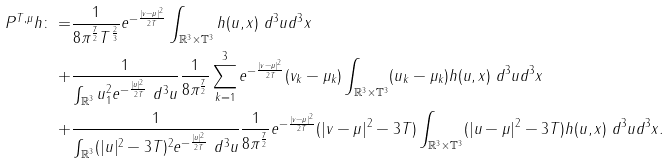<formula> <loc_0><loc_0><loc_500><loc_500>P ^ { T , \mu } h \colon = & \frac { 1 } { 8 \pi ^ { \frac { 7 } { 2 } } T ^ { \frac { 2 } { 3 } } } e ^ { - \frac { | v - \mu | ^ { 2 } } { 2 T } } \int _ { \mathbb { R } ^ { 3 } \times \mathbb { T } ^ { 3 } } h ( u , x ) \ d ^ { 3 } u d ^ { 3 } x \\ + & \frac { 1 } { \int _ { \mathbb { R } ^ { 3 } } u _ { 1 } ^ { 2 } e ^ { - \frac { | u | ^ { 2 } } { 2 T } } \ d ^ { 3 } u } \frac { 1 } { 8 \pi ^ { \frac { 7 } { 2 } } } \sum _ { k = 1 } ^ { 3 } e ^ { - \frac { | v - \mu | ^ { 2 } } { 2 T } } ( v _ { k } - \mu _ { k } ) \int _ { \mathbb { R } ^ { 3 } \times \mathbb { T } ^ { 3 } } ( u _ { k } - \mu _ { k } ) h ( u , x ) \ d ^ { 3 } u d ^ { 3 } x \\ + & \frac { 1 } { \int _ { \mathbb { R } ^ { 3 } } ( | u | ^ { 2 } - 3 T ) ^ { 2 } e ^ { - \frac { | u | ^ { 2 } } { 2 T } } \ d ^ { 3 } u } \frac { 1 } { 8 \pi ^ { \frac { 7 } { 2 } } } e ^ { - \frac { | v - \mu | ^ { 2 } } { 2 T } } ( | v - \mu | ^ { 2 } - 3 T ) \int _ { \mathbb { R } ^ { 3 } \times \mathbb { T } ^ { 3 } } ( | u - \mu | ^ { 2 } - 3 T ) h ( u , x ) \ d ^ { 3 } u d ^ { 3 } x .</formula> 